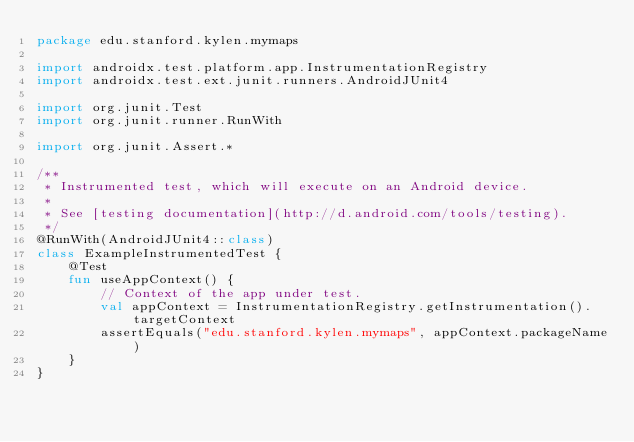<code> <loc_0><loc_0><loc_500><loc_500><_Kotlin_>package edu.stanford.kylen.mymaps

import androidx.test.platform.app.InstrumentationRegistry
import androidx.test.ext.junit.runners.AndroidJUnit4

import org.junit.Test
import org.junit.runner.RunWith

import org.junit.Assert.*

/**
 * Instrumented test, which will execute on an Android device.
 *
 * See [testing documentation](http://d.android.com/tools/testing).
 */
@RunWith(AndroidJUnit4::class)
class ExampleInstrumentedTest {
    @Test
    fun useAppContext() {
        // Context of the app under test.
        val appContext = InstrumentationRegistry.getInstrumentation().targetContext
        assertEquals("edu.stanford.kylen.mymaps", appContext.packageName)
    }
}
</code> 